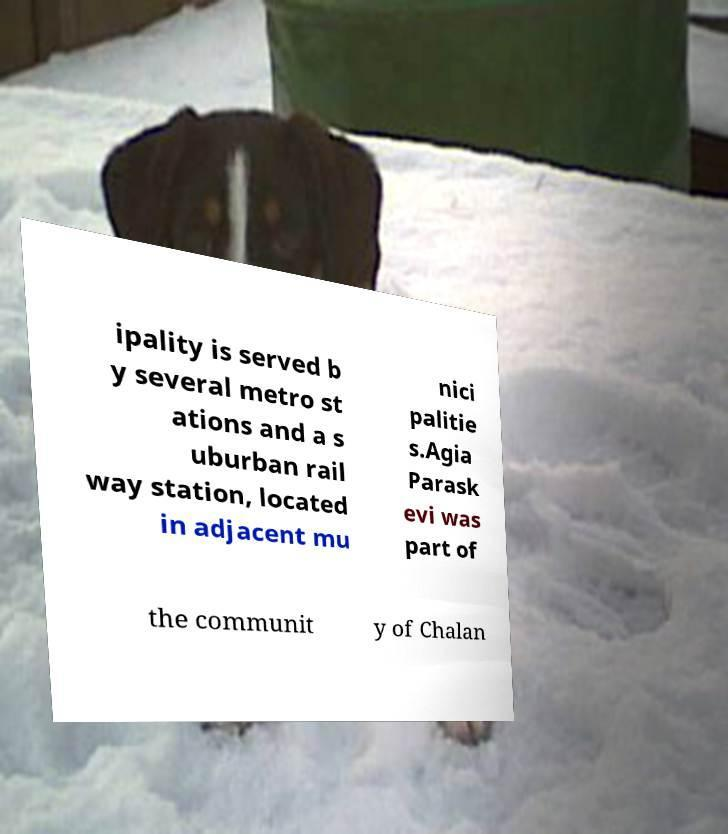Please identify and transcribe the text found in this image. ipality is served b y several metro st ations and a s uburban rail way station, located in adjacent mu nici palitie s.Agia Parask evi was part of the communit y of Chalan 